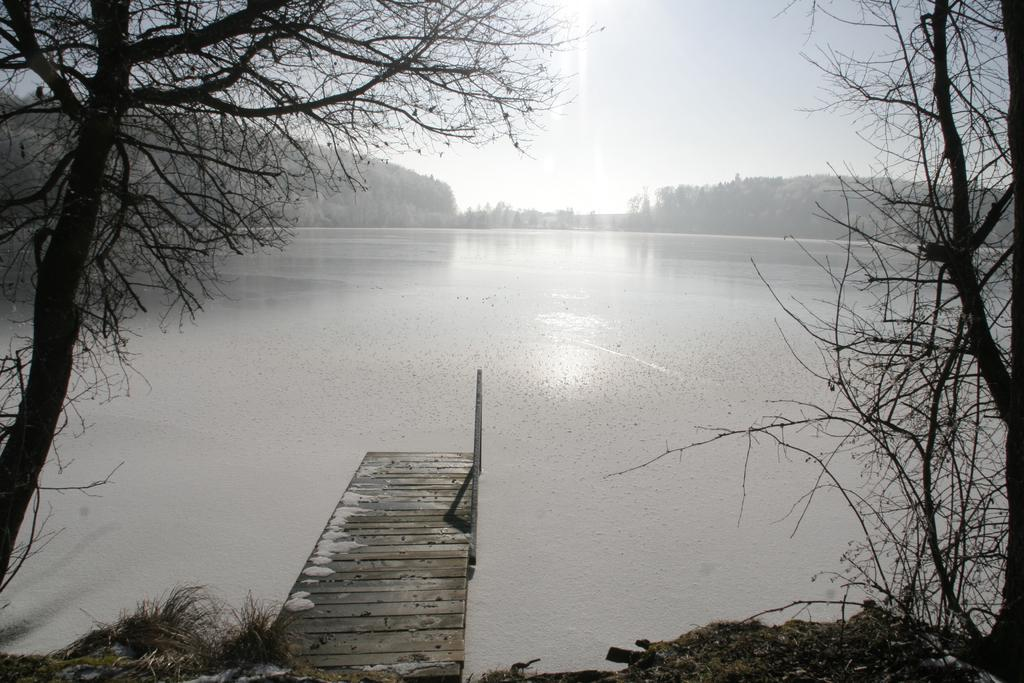What structure is located at the center of the image? There is a bridge in the image, and it is at the center of the image. What is in front of the bridge? There is a river in front of the bridge. What can be seen in the background of the image? There are trees and the sky visible in the background of the image. Who is the creator of the baseball that can be seen on the bridge? There is no baseball present in the image, so it is not possible to determine who created it. 